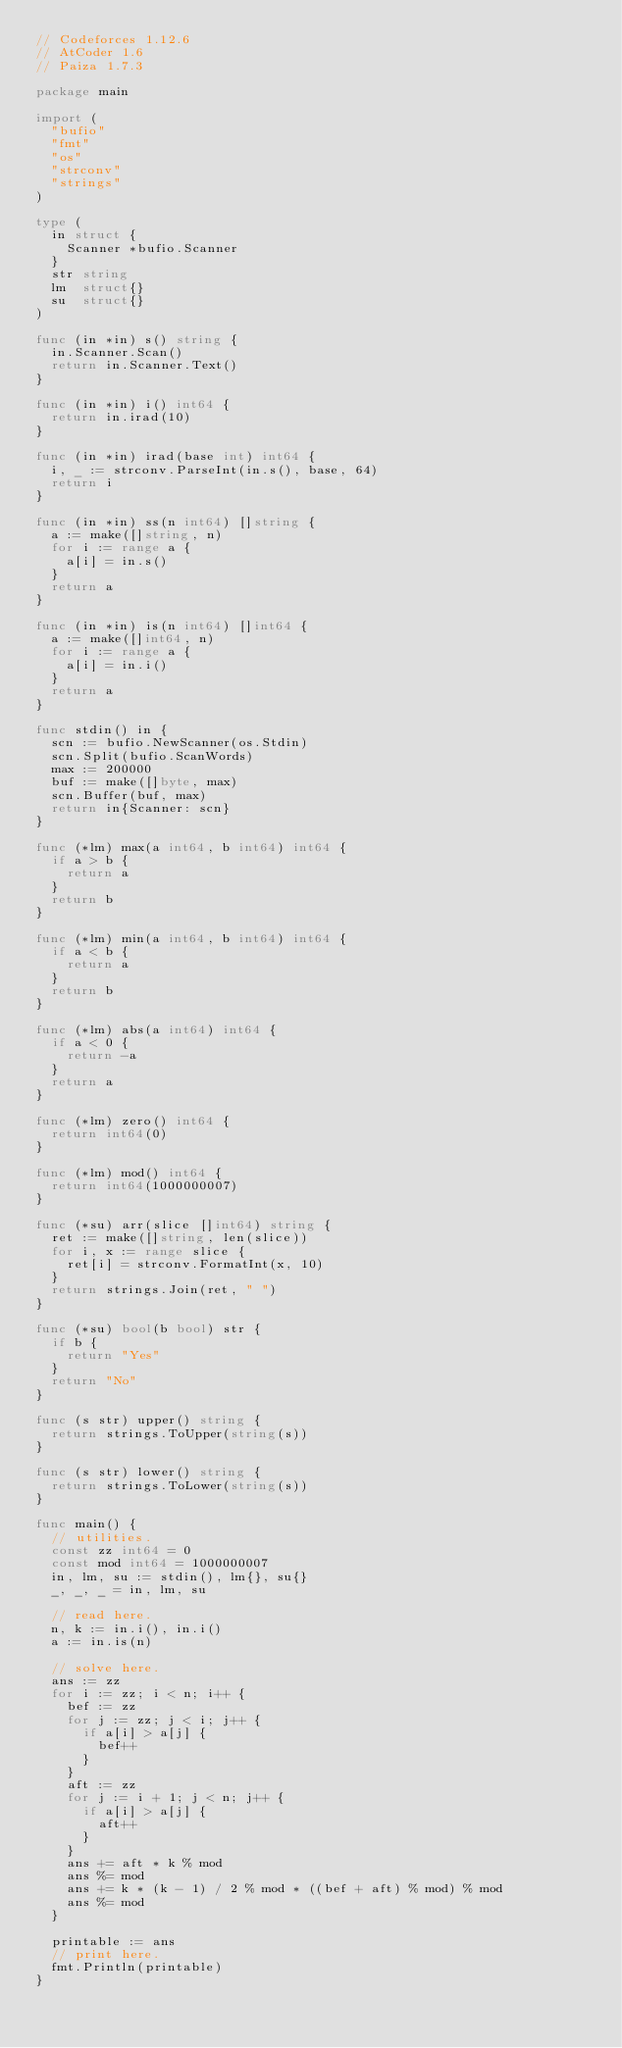<code> <loc_0><loc_0><loc_500><loc_500><_Go_>// Codeforces 1.12.6
// AtCoder 1.6
// Paiza 1.7.3

package main

import (
	"bufio"
	"fmt"
	"os"
	"strconv"
	"strings"
)

type (
	in struct {
		Scanner *bufio.Scanner
	}
	str string
	lm  struct{}
	su  struct{}
)

func (in *in) s() string {
	in.Scanner.Scan()
	return in.Scanner.Text()
}

func (in *in) i() int64 {
	return in.irad(10)
}

func (in *in) irad(base int) int64 {
	i, _ := strconv.ParseInt(in.s(), base, 64)
	return i
}

func (in *in) ss(n int64) []string {
	a := make([]string, n)
	for i := range a {
		a[i] = in.s()
	}
	return a
}

func (in *in) is(n int64) []int64 {
	a := make([]int64, n)
	for i := range a {
		a[i] = in.i()
	}
	return a
}

func stdin() in {
	scn := bufio.NewScanner(os.Stdin)
	scn.Split(bufio.ScanWords)
	max := 200000
	buf := make([]byte, max)
	scn.Buffer(buf, max)
	return in{Scanner: scn}
}

func (*lm) max(a int64, b int64) int64 {
	if a > b {
		return a
	}
	return b
}

func (*lm) min(a int64, b int64) int64 {
	if a < b {
		return a
	}
	return b
}

func (*lm) abs(a int64) int64 {
	if a < 0 {
		return -a
	}
	return a
}

func (*lm) zero() int64 {
	return int64(0)
}

func (*lm) mod() int64 {
	return int64(1000000007)
}

func (*su) arr(slice []int64) string {
	ret := make([]string, len(slice))
	for i, x := range slice {
		ret[i] = strconv.FormatInt(x, 10)
	}
	return strings.Join(ret, " ")
}

func (*su) bool(b bool) str {
	if b {
		return "Yes"
	}
	return "No"
}

func (s str) upper() string {
	return strings.ToUpper(string(s))
}

func (s str) lower() string {
	return strings.ToLower(string(s))
}

func main() {
	// utilities.
	const zz int64 = 0
	const mod int64 = 1000000007
	in, lm, su := stdin(), lm{}, su{}
	_, _, _ = in, lm, su

	// read here.
	n, k := in.i(), in.i()
	a := in.is(n)

	// solve here.
	ans := zz
	for i := zz; i < n; i++ {
		bef := zz
		for j := zz; j < i; j++ {
			if a[i] > a[j] {
				bef++
			}
		}
		aft := zz
		for j := i + 1; j < n; j++ {
			if a[i] > a[j] {
				aft++
			}
		}
		ans += aft * k % mod
		ans %= mod
		ans += k * (k - 1) / 2 % mod * ((bef + aft) % mod) % mod
		ans %= mod
	}

	printable := ans
	// print here.
	fmt.Println(printable)
}
</code> 